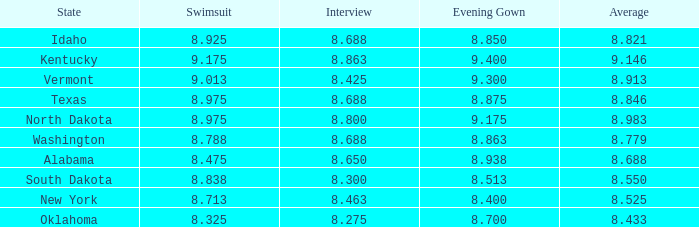What is the average interview score from Kentucky? 8.863. 